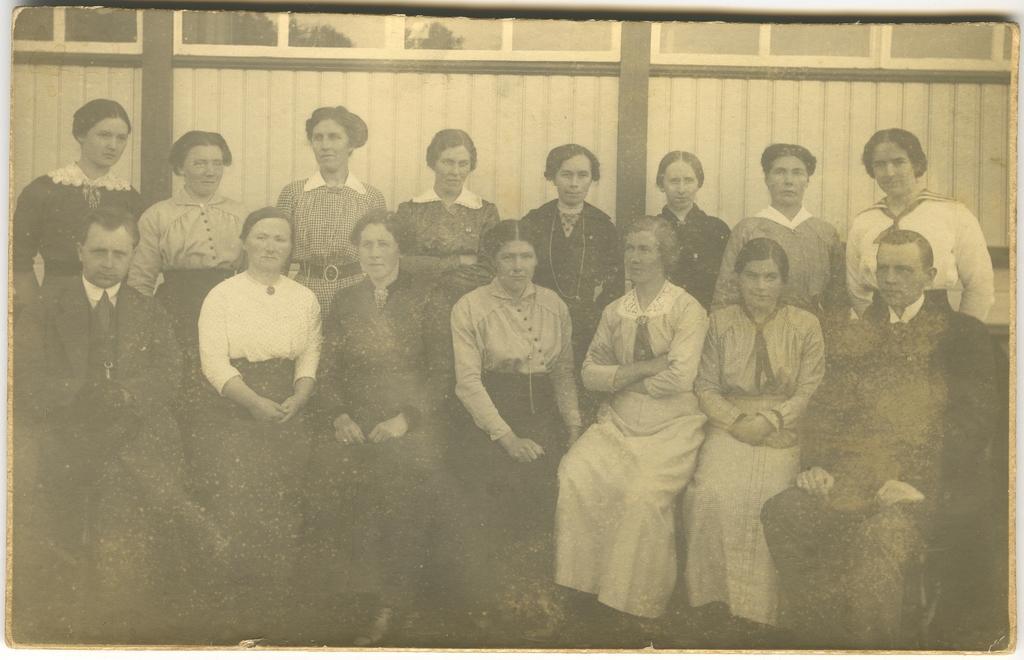Describe this image in one or two sentences. In this image I can see the photo. In the photo I can see the group of people with dresses. In the background i can see the building. And this is an old photo. 